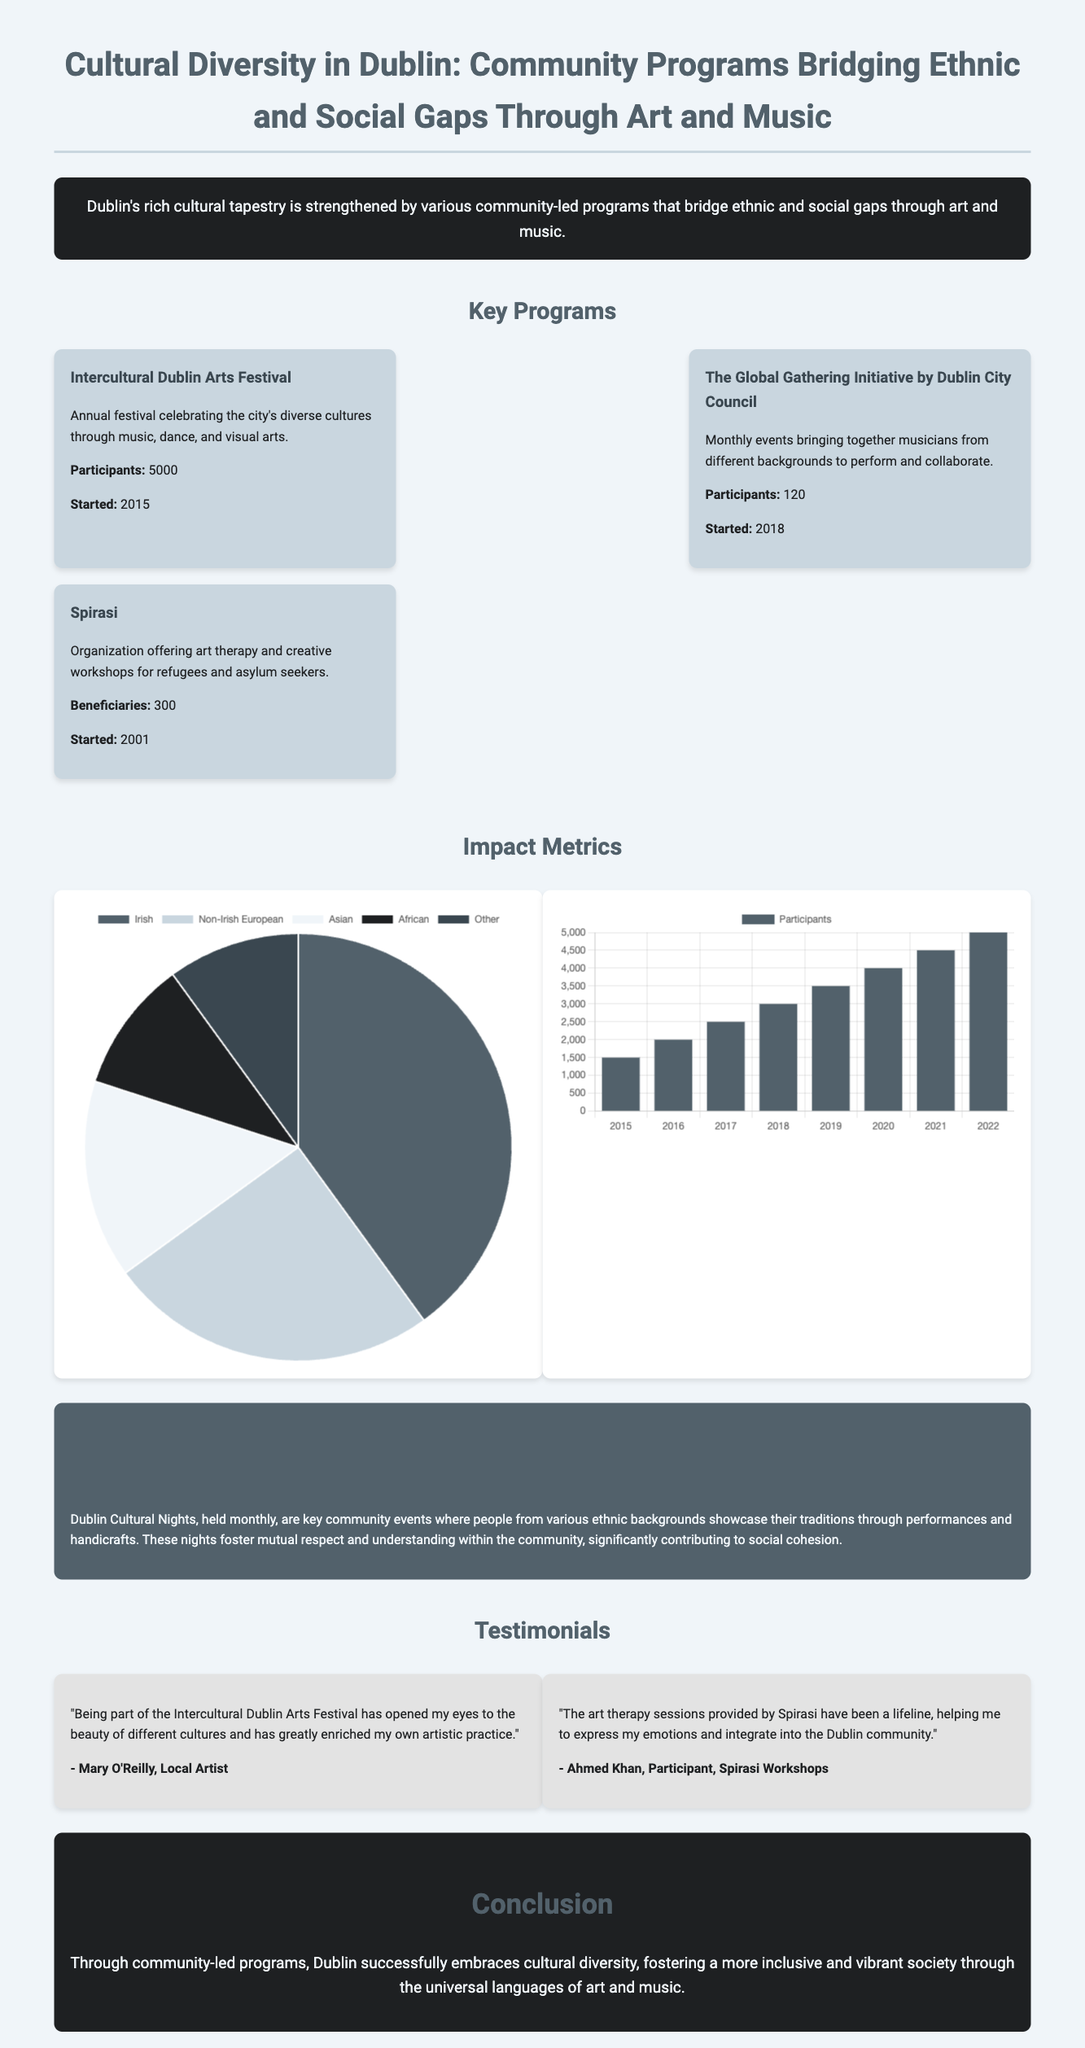What is the name of the annual festival? The annual festival that celebrates Dublin's diverse cultures through music, dance, and visual arts is mentioned in the document.
Answer: Intercultural Dublin Arts Festival How many participants does the Global Gathering Initiative attract? The document provides the number of participants for various programs, specifically for the Global Gathering Initiative.
Answer: 120 In which year did Spirasi start? The year Spirasi began its operations is provided in the document as part of its description.
Answer: 2001 What percentage of participants are of Irish descent? The participant demographics pie chart in the document specifies the percentage of participants identifying as Irish.
Answer: 40 What was the number of participants in 2019? The annual growth chart in the document allows for easy retrieval of the number of participants for a specific year.
Answer: 3500 Which program offers art therapy? The document lists several community programs and specifies which one provides art therapy for a particular group.
Answer: Spirasi What is the main theme of Dublin Cultural Nights? The main activity or theme of these monthly community events is discussed in the case study section of the document.
Answer: Showcase traditions What color represents non-Irish Europeans in the demographics chart? The demographics chart assigns specific colors to different ethnic groups, including non-Irish Europeans.
Answer: Light gray How has participation changed from 2020 to 2021? The annual growth data in the document reflects the change in participation numbers from 2020 to 2021 and requires simple calculation.
Answer: Increased by 500 